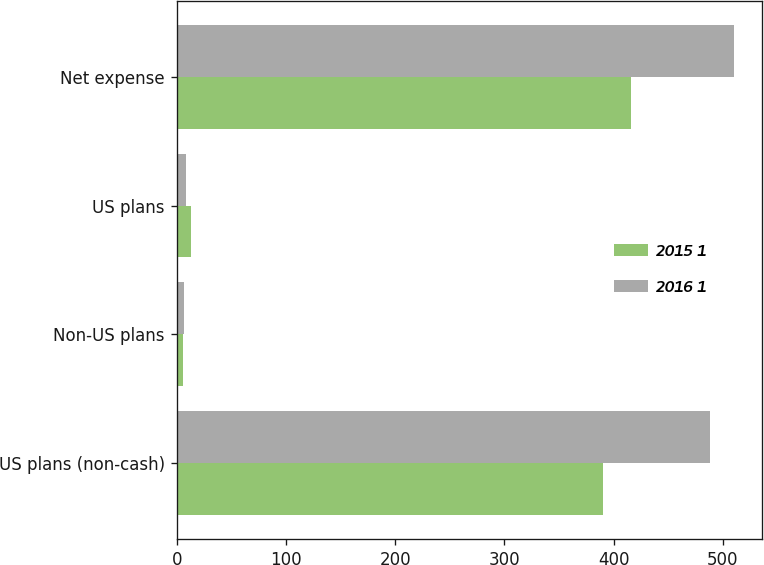Convert chart. <chart><loc_0><loc_0><loc_500><loc_500><stacked_bar_chart><ecel><fcel>US plans (non-cash)<fcel>Non-US plans<fcel>US plans<fcel>Net expense<nl><fcel>2015 1<fcel>390<fcel>6<fcel>13<fcel>416<nl><fcel>2016 1<fcel>488<fcel>7<fcel>9<fcel>510<nl></chart> 